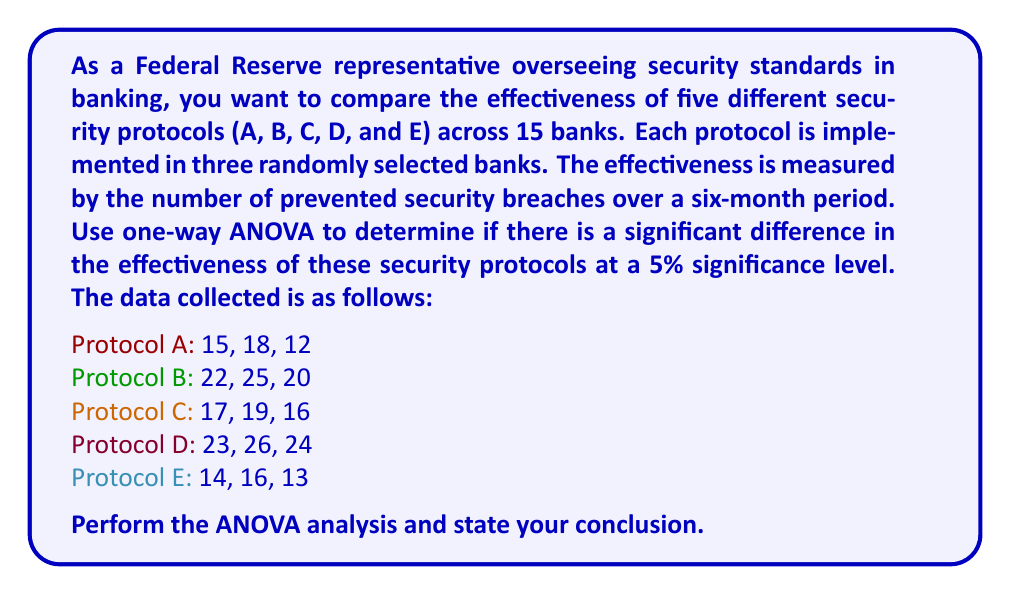Help me with this question. To perform a one-way ANOVA, we'll follow these steps:

1. Calculate the sum of squares between groups (SSB) and within groups (SSW)
2. Calculate the degrees of freedom for between groups (dfB) and within groups (dfW)
3. Calculate the mean squares between groups (MSB) and within groups (MSW)
4. Calculate the F-statistic
5. Compare the F-statistic to the critical F-value

Step 1: Calculate SSB and SSW

First, we need to calculate the grand mean:
$$\bar{X} = \frac{15 + 18 + 12 + 22 + 25 + 20 + 17 + 19 + 16 + 23 + 26 + 24 + 14 + 16 + 13}{15} = 18.67$$

Now, we calculate SSB:
$$SSB = 3[(15+18+12)/3 - 18.67]^2 + 3[(22+25+20)/3 - 18.67]^2 + 3[(17+19+16)/3 - 18.67]^2 + 3[(23+26+24)/3 - 18.67]^2 + 3[(14+16+13)/3 - 18.67]^2$$
$$SSB = 3(-3.67)^2 + 3(3.33)^2 + 3(-1.00)^2 + 3(5.33)^2 + 3(-4.00)^2 = 228.93$$

For SSW, we calculate the sum of squared deviations within each group:
$$SSW = (15-15)^2 + (18-15)^2 + (12-15)^2 + (22-22.33)^2 + (25-22.33)^2 + (20-22.33)^2 + ... + (14-14.33)^2 + (16-14.33)^2 + (13-14.33)^2$$
$$SSW = 18 + 6.22 + 4.67 + 4.67 + 4.67 = 38.23$$

Step 2: Calculate degrees of freedom

$$df_B = k - 1 = 5 - 1 = 4$$
$$df_W = N - k = 15 - 5 = 10$$

Where k is the number of groups and N is the total number of observations.

Step 3: Calculate mean squares

$$MSB = \frac{SSB}{df_B} = \frac{228.93}{4} = 57.23$$
$$MSW = \frac{SSW}{df_W} = \frac{38.23}{10} = 3.82$$

Step 4: Calculate F-statistic

$$F = \frac{MSB}{MSW} = \frac{57.23}{3.82} = 14.98$$

Step 5: Compare F-statistic to critical F-value

The critical F-value for $\alpha = 0.05$, $df_B = 4$, and $df_W = 10$ is approximately 3.48.

Since our calculated F-statistic (14.98) is greater than the critical F-value (3.48), we reject the null hypothesis.
Answer: We reject the null hypothesis at the 5% significance level. There is strong evidence to suggest that there are significant differences in the effectiveness of the five security protocols in preventing security breaches. 